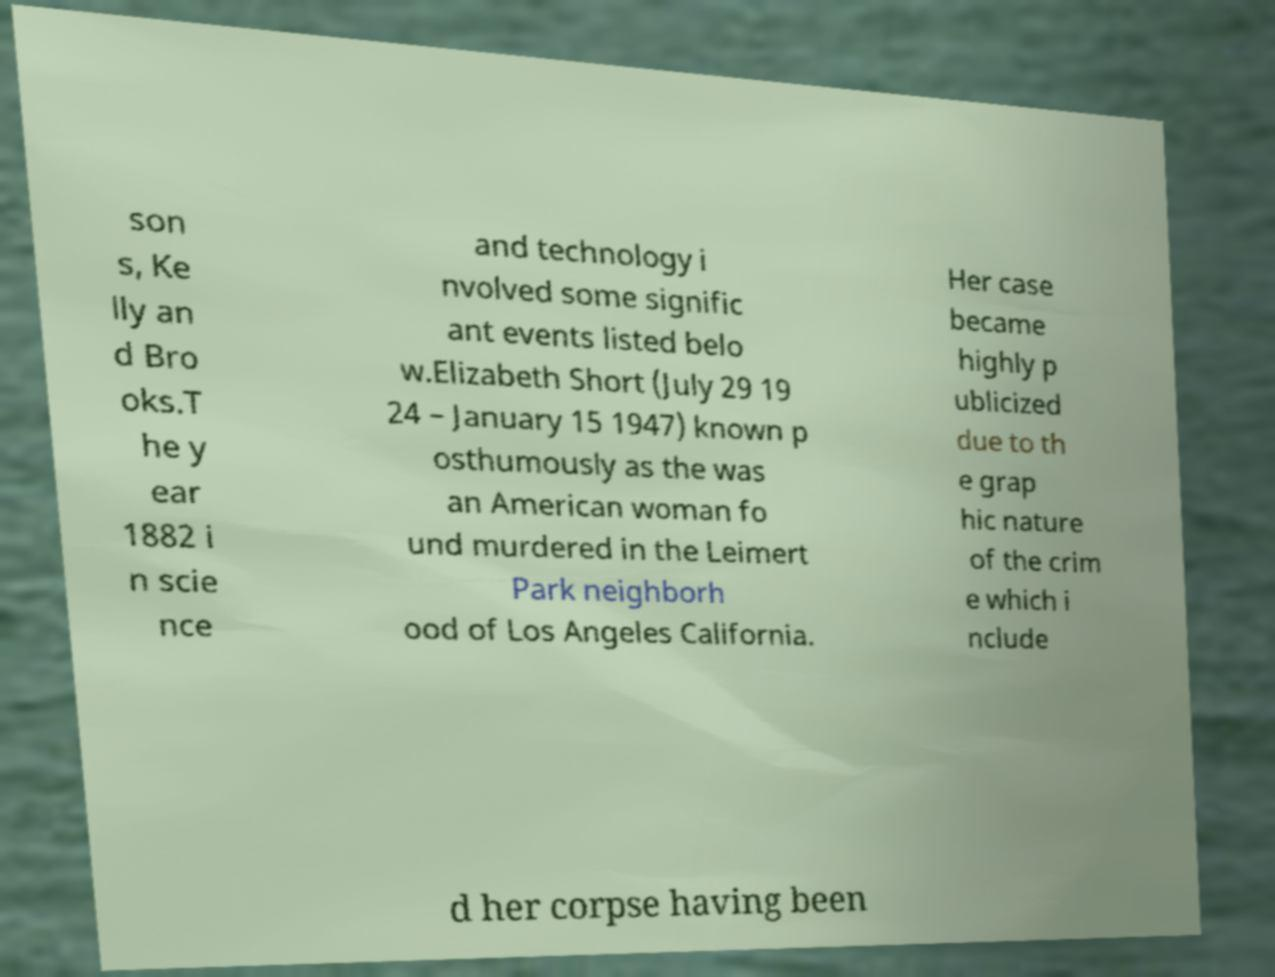Please read and relay the text visible in this image. What does it say? son s, Ke lly an d Bro oks.T he y ear 1882 i n scie nce and technology i nvolved some signific ant events listed belo w.Elizabeth Short (July 29 19 24 – January 15 1947) known p osthumously as the was an American woman fo und murdered in the Leimert Park neighborh ood of Los Angeles California. Her case became highly p ublicized due to th e grap hic nature of the crim e which i nclude d her corpse having been 